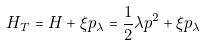<formula> <loc_0><loc_0><loc_500><loc_500>H _ { T } = H + \xi p _ { \lambda } = \frac { 1 } { 2 } \lambda p ^ { 2 } + \xi p _ { \lambda }</formula> 